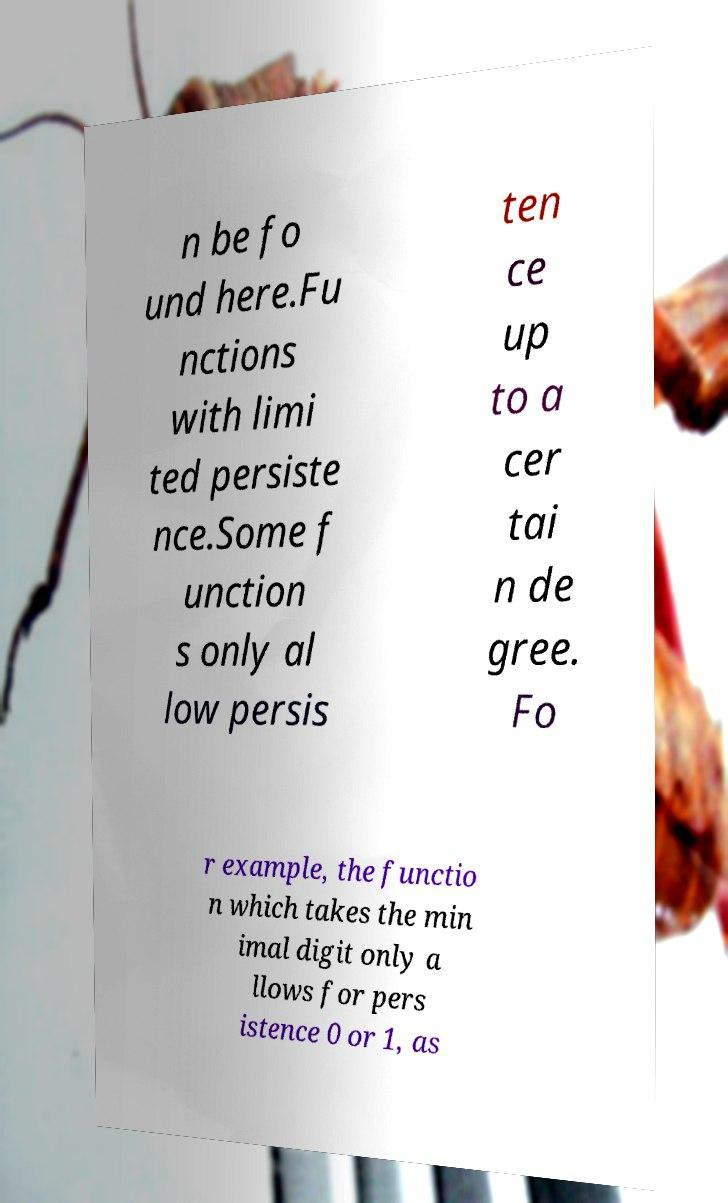There's text embedded in this image that I need extracted. Can you transcribe it verbatim? n be fo und here.Fu nctions with limi ted persiste nce.Some f unction s only al low persis ten ce up to a cer tai n de gree. Fo r example, the functio n which takes the min imal digit only a llows for pers istence 0 or 1, as 